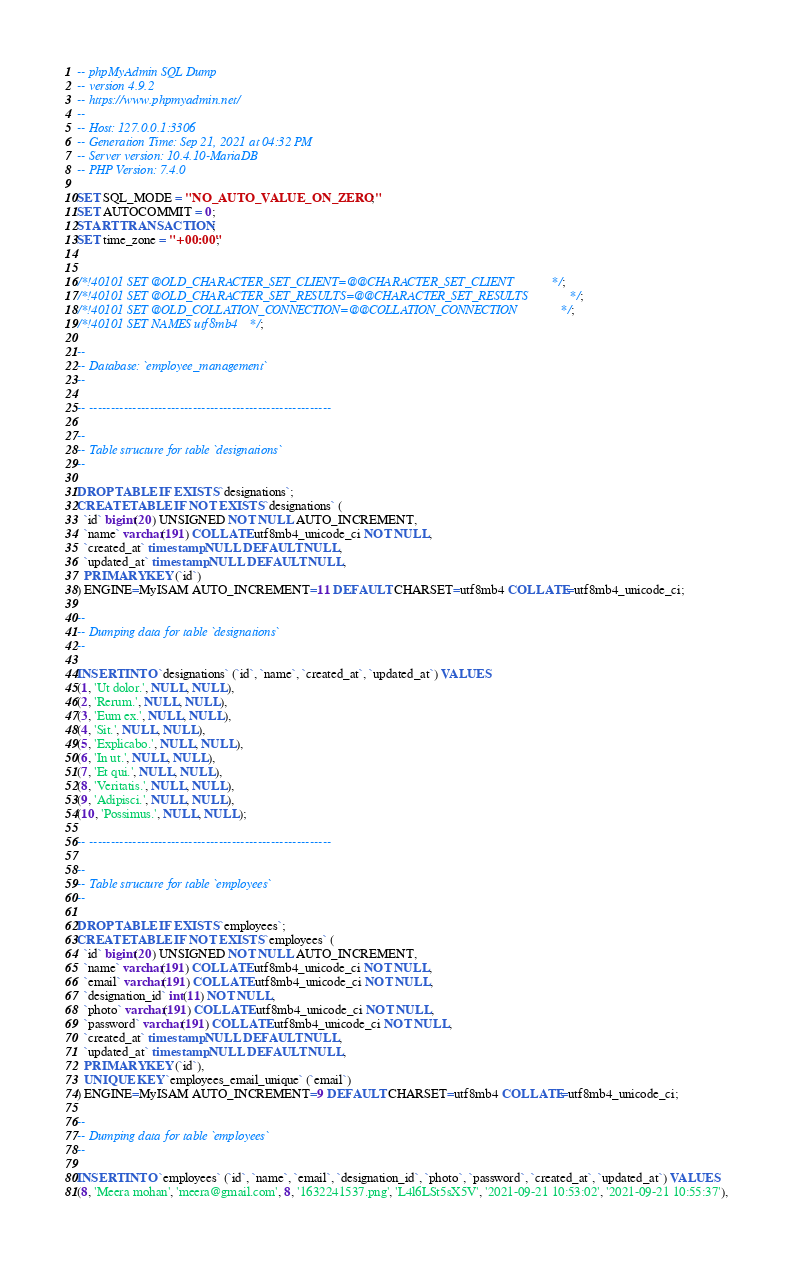Convert code to text. <code><loc_0><loc_0><loc_500><loc_500><_SQL_>-- phpMyAdmin SQL Dump
-- version 4.9.2
-- https://www.phpmyadmin.net/
--
-- Host: 127.0.0.1:3306
-- Generation Time: Sep 21, 2021 at 04:32 PM
-- Server version: 10.4.10-MariaDB
-- PHP Version: 7.4.0

SET SQL_MODE = "NO_AUTO_VALUE_ON_ZERO";
SET AUTOCOMMIT = 0;
START TRANSACTION;
SET time_zone = "+00:00";


/*!40101 SET @OLD_CHARACTER_SET_CLIENT=@@CHARACTER_SET_CLIENT */;
/*!40101 SET @OLD_CHARACTER_SET_RESULTS=@@CHARACTER_SET_RESULTS */;
/*!40101 SET @OLD_COLLATION_CONNECTION=@@COLLATION_CONNECTION */;
/*!40101 SET NAMES utf8mb4 */;

--
-- Database: `employee_management`
--

-- --------------------------------------------------------

--
-- Table structure for table `designations`
--

DROP TABLE IF EXISTS `designations`;
CREATE TABLE IF NOT EXISTS `designations` (
  `id` bigint(20) UNSIGNED NOT NULL AUTO_INCREMENT,
  `name` varchar(191) COLLATE utf8mb4_unicode_ci NOT NULL,
  `created_at` timestamp NULL DEFAULT NULL,
  `updated_at` timestamp NULL DEFAULT NULL,
  PRIMARY KEY (`id`)
) ENGINE=MyISAM AUTO_INCREMENT=11 DEFAULT CHARSET=utf8mb4 COLLATE=utf8mb4_unicode_ci;

--
-- Dumping data for table `designations`
--

INSERT INTO `designations` (`id`, `name`, `created_at`, `updated_at`) VALUES
(1, 'Ut dolor.', NULL, NULL),
(2, 'Rerum.', NULL, NULL),
(3, 'Eum ex.', NULL, NULL),
(4, 'Sit.', NULL, NULL),
(5, 'Explicabo.', NULL, NULL),
(6, 'In ut.', NULL, NULL),
(7, 'Et qui.', NULL, NULL),
(8, 'Veritatis.', NULL, NULL),
(9, 'Adipisci.', NULL, NULL),
(10, 'Possimus.', NULL, NULL);

-- --------------------------------------------------------

--
-- Table structure for table `employees`
--

DROP TABLE IF EXISTS `employees`;
CREATE TABLE IF NOT EXISTS `employees` (
  `id` bigint(20) UNSIGNED NOT NULL AUTO_INCREMENT,
  `name` varchar(191) COLLATE utf8mb4_unicode_ci NOT NULL,
  `email` varchar(191) COLLATE utf8mb4_unicode_ci NOT NULL,
  `designation_id` int(11) NOT NULL,
  `photo` varchar(191) COLLATE utf8mb4_unicode_ci NOT NULL,
  `password` varchar(191) COLLATE utf8mb4_unicode_ci NOT NULL,
  `created_at` timestamp NULL DEFAULT NULL,
  `updated_at` timestamp NULL DEFAULT NULL,
  PRIMARY KEY (`id`),
  UNIQUE KEY `employees_email_unique` (`email`)
) ENGINE=MyISAM AUTO_INCREMENT=9 DEFAULT CHARSET=utf8mb4 COLLATE=utf8mb4_unicode_ci;

--
-- Dumping data for table `employees`
--

INSERT INTO `employees` (`id`, `name`, `email`, `designation_id`, `photo`, `password`, `created_at`, `updated_at`) VALUES
(8, 'Meera mohan', 'meera@gmail.com', 8, '1632241537.png', 'L4l6LSt5sX5V', '2021-09-21 10:53:02', '2021-09-21 10:55:37'),</code> 